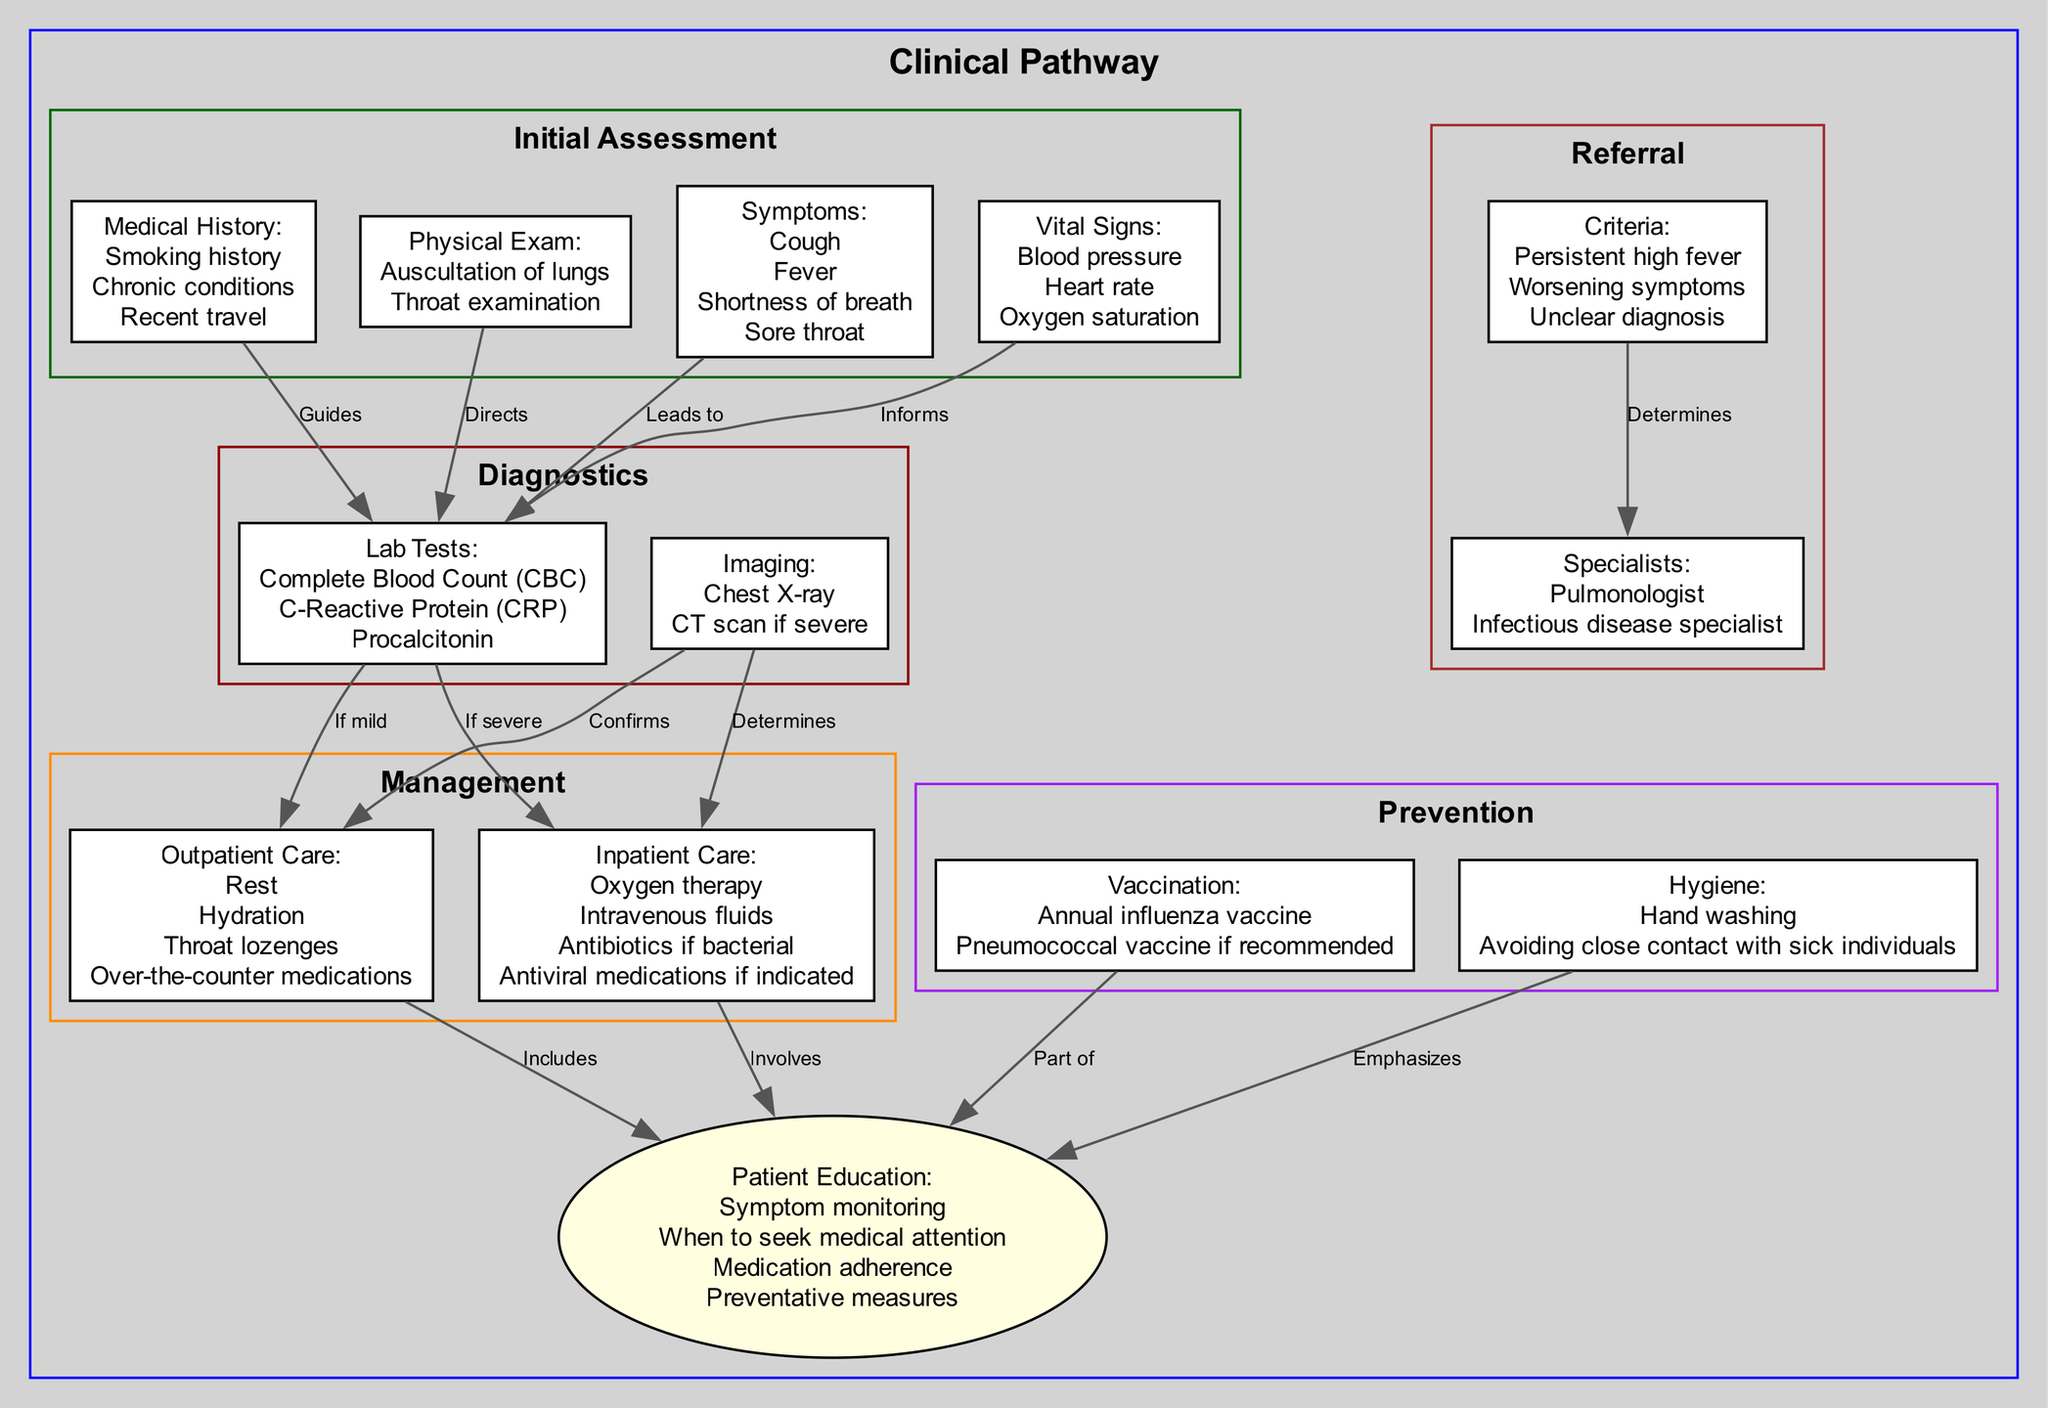What are the symptoms listed in the initial assessment? The "Initial Assessment" section includes a node labeled "Symptoms," which lists Cough, Fever, Shortness of breath, and Sore throat as the symptoms.
Answer: Cough, Fever, Shortness of breath, Sore throat How many lab tests are mentioned in the diagnostics? There is a node labeled "Lab Tests" under the "Diagnostics" section that lists three specific tests: Complete Blood Count, C-Reactive Protein, and Procalcitonin. Thus, the total number of lab tests is three.
Answer: 3 What leads to outpatient care? The diagram shows that the arrow from the "Lab Tests" node to the "Outpatient Care" node indicates that lab results lead to outpatient care if symptoms are mild.
Answer: Lab tests What type of care is indicated for severe symptoms? The "Inpatient Care" node is directly connected to the "Inpatient Care" label in the management section, indicating that this type of care is appropriate for severe symptoms.
Answer: Inpatient care Which vaccination is part of the preventative measures? In the "Prevention" section, a node indicates that the "Annual influenza vaccine" is one of the vaccination methods for prevention, as highlighted in the relevant node.
Answer: Annual influenza vaccine What determines the type of specialists referred? The "Referral" section has a node that lists "Criteria" which includes Persistent high fever, Worsening symptoms, and Unclear diagnosis. These criteria inform the decision to refer to specialists.
Answer: Criteria What is included in patient education? Under the "Patient Education" node, there is a list that includes topics such as Symptom monitoring, When to seek medical attention, and Preventative measures, indicating the subjects covered in patient education.
Answer: Symptom monitoring, When to seek medical attention, Preventative measures Which management option includes hydration? The "Outpatient Care" node under "Management" lists hydration among other mild symptom treatments, indicating it is included in outpatient management.
Answer: Outpatient care How do imaging results affect inpatient care? The diagram shows an edge connecting "Imaging" to "Inpatient Care," indicating that imaging results determine the approach and necessary steps in inpatient care management.
Answer: Determines 